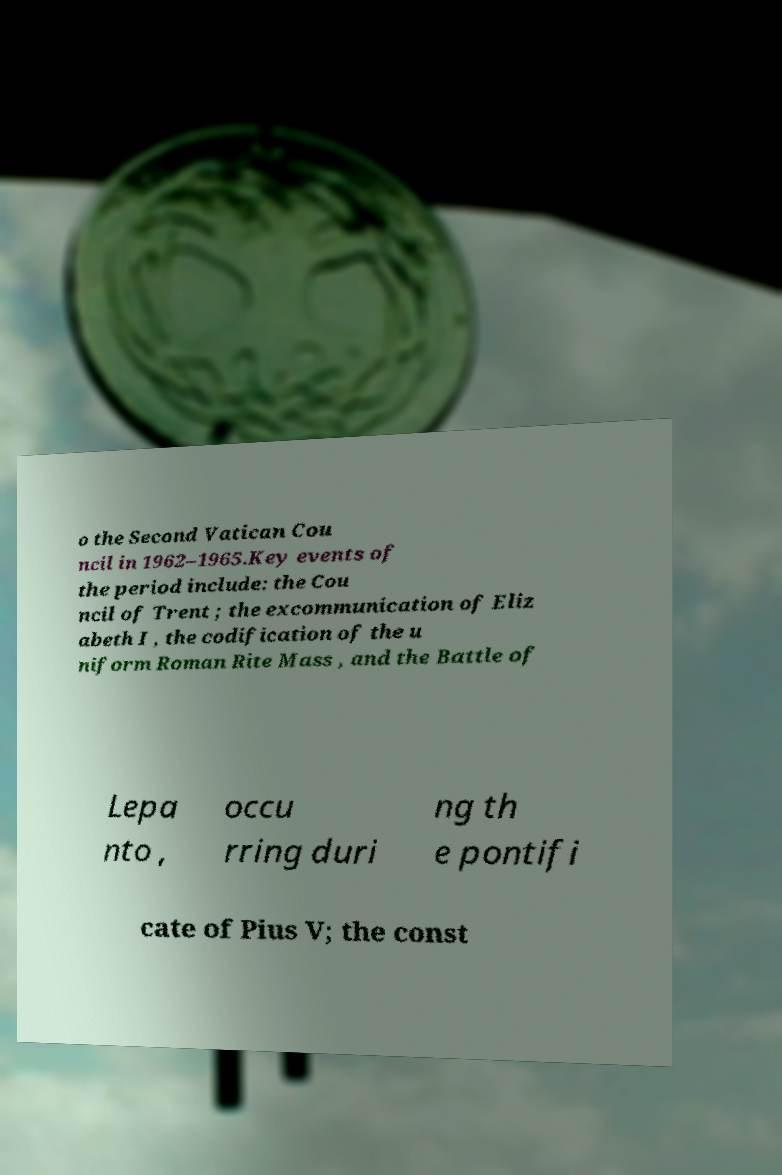Can you read and provide the text displayed in the image?This photo seems to have some interesting text. Can you extract and type it out for me? o the Second Vatican Cou ncil in 1962–1965.Key events of the period include: the Cou ncil of Trent ; the excommunication of Eliz abeth I , the codification of the u niform Roman Rite Mass , and the Battle of Lepa nto , occu rring duri ng th e pontifi cate of Pius V; the const 